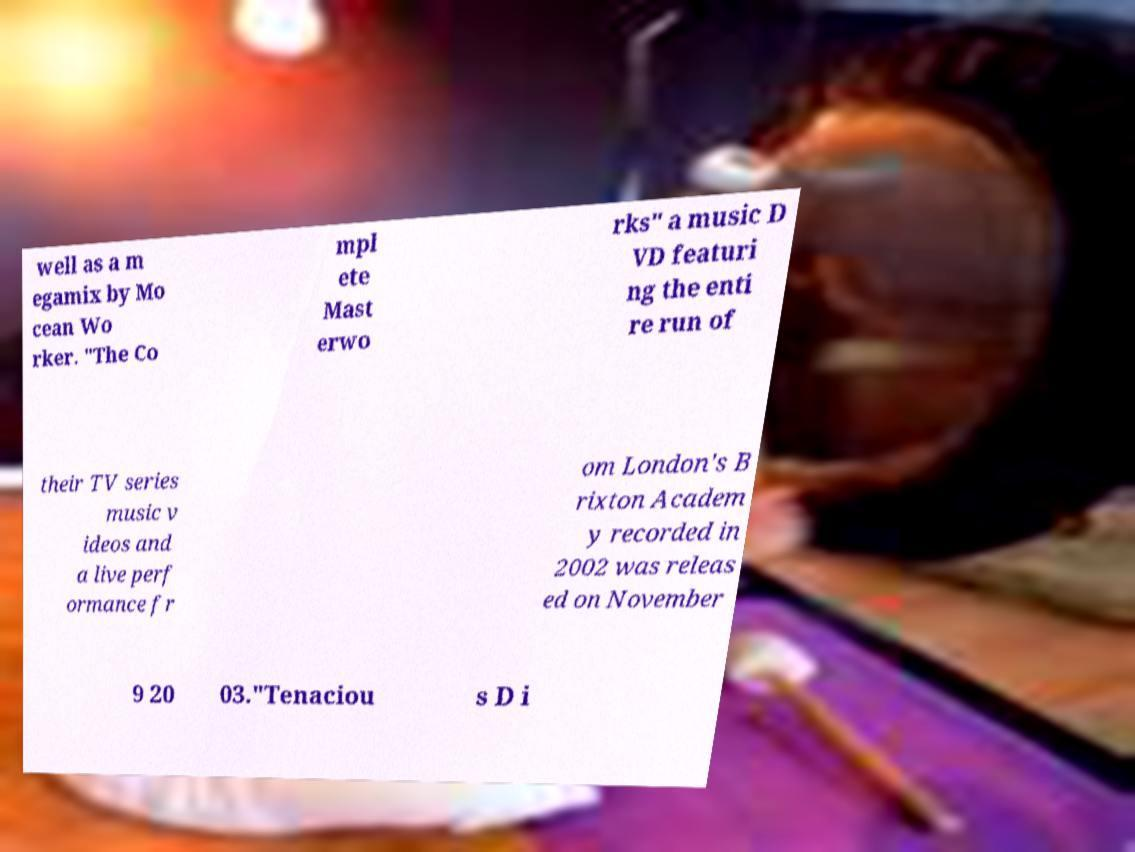Could you extract and type out the text from this image? well as a m egamix by Mo cean Wo rker. "The Co mpl ete Mast erwo rks" a music D VD featuri ng the enti re run of their TV series music v ideos and a live perf ormance fr om London's B rixton Academ y recorded in 2002 was releas ed on November 9 20 03."Tenaciou s D i 